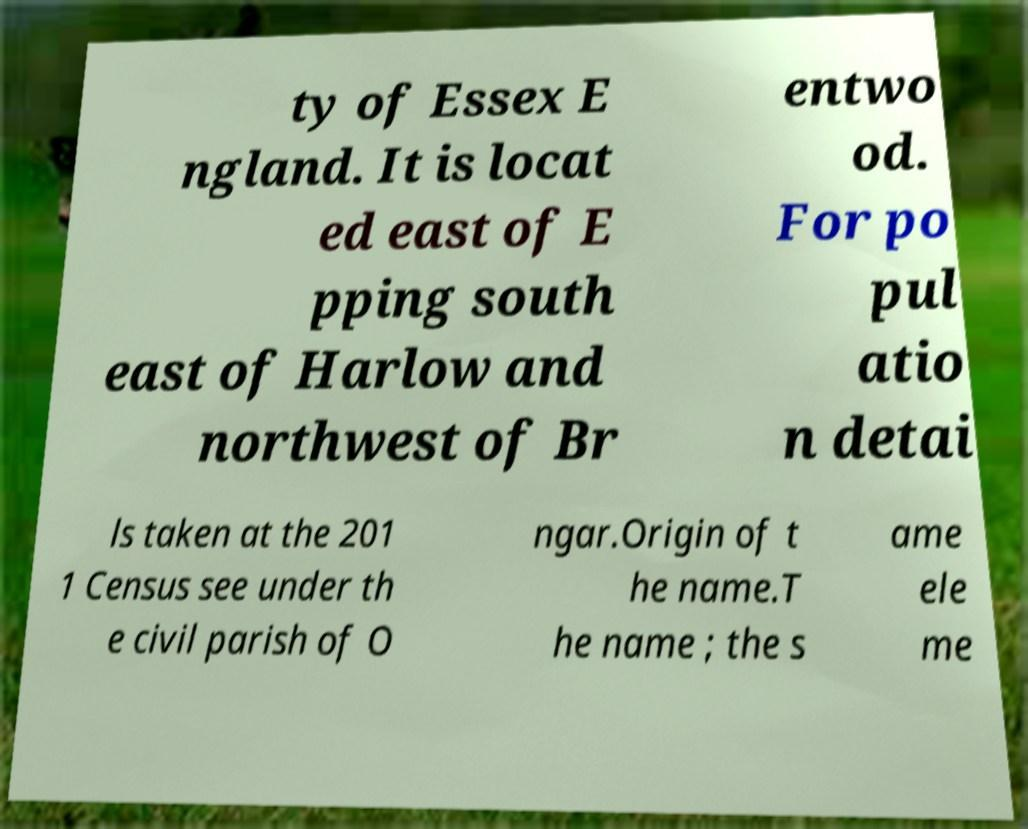Please read and relay the text visible in this image. What does it say? ty of Essex E ngland. It is locat ed east of E pping south east of Harlow and northwest of Br entwo od. For po pul atio n detai ls taken at the 201 1 Census see under th e civil parish of O ngar.Origin of t he name.T he name ; the s ame ele me 